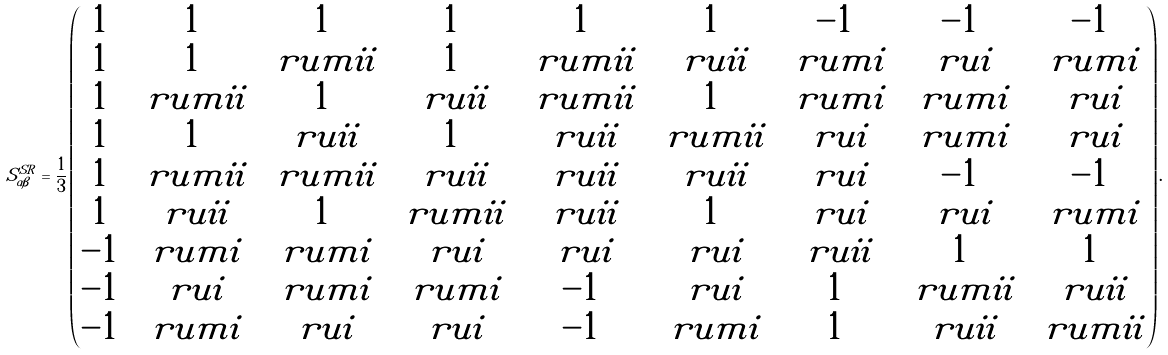<formula> <loc_0><loc_0><loc_500><loc_500>S ^ { S R } _ { \alpha \beta } = \frac { 1 } { 3 } \begin{pmatrix} 1 & 1 & 1 & 1 & 1 & 1 & - 1 & - 1 & - 1 \\ 1 & 1 & \ r u m i i & 1 & \ r u m i i & \ r u i i & \ r u m i & \ r u i & \ r u m i \\ 1 & \ r u m i i & 1 & \ r u i i & \ r u m i i & 1 & \ r u m i & \ r u m i & \ r u i \\ 1 & 1 & \ r u i i & 1 & \ r u i i & \ r u m i i & \ r u i & \ r u m i & \ r u i \\ 1 & \ r u m i i & \ r u m i i & \ r u i i & \ r u i i & \ r u i i & \ r u i & - 1 & - 1 \\ 1 & \ r u i i & 1 & \ r u m i i & \ r u i i & 1 & \ r u i & \ r u i & \ r u m i \\ - 1 & \ r u m i & \ r u m i & \ r u i & \ r u i & \ r u i & \ r u i i & 1 & 1 \\ - 1 & \ r u i & \ r u m i & \ r u m i & - 1 & \ r u i & 1 & \ r u m i i & \ r u i i \\ - 1 & \ r u m i & \ r u i & \ r u i & - 1 & \ r u m i & 1 & \ r u i i & \ r u m i i \end{pmatrix} .</formula> 